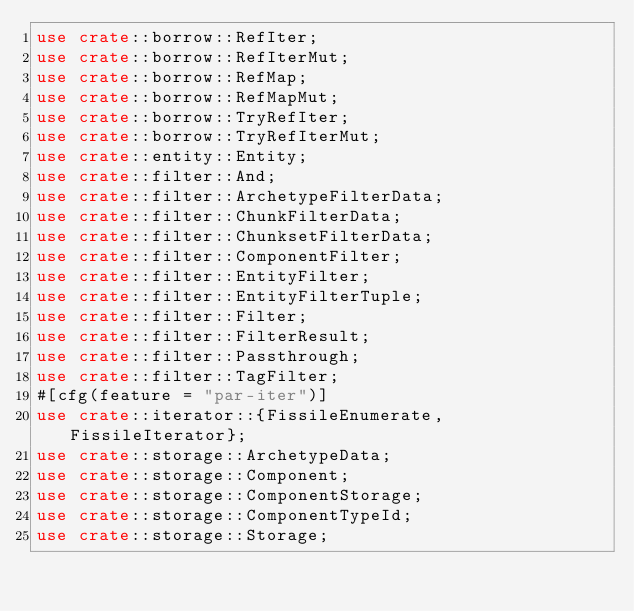<code> <loc_0><loc_0><loc_500><loc_500><_Rust_>use crate::borrow::RefIter;
use crate::borrow::RefIterMut;
use crate::borrow::RefMap;
use crate::borrow::RefMapMut;
use crate::borrow::TryRefIter;
use crate::borrow::TryRefIterMut;
use crate::entity::Entity;
use crate::filter::And;
use crate::filter::ArchetypeFilterData;
use crate::filter::ChunkFilterData;
use crate::filter::ChunksetFilterData;
use crate::filter::ComponentFilter;
use crate::filter::EntityFilter;
use crate::filter::EntityFilterTuple;
use crate::filter::Filter;
use crate::filter::FilterResult;
use crate::filter::Passthrough;
use crate::filter::TagFilter;
#[cfg(feature = "par-iter")]
use crate::iterator::{FissileEnumerate, FissileIterator};
use crate::storage::ArchetypeData;
use crate::storage::Component;
use crate::storage::ComponentStorage;
use crate::storage::ComponentTypeId;
use crate::storage::Storage;</code> 